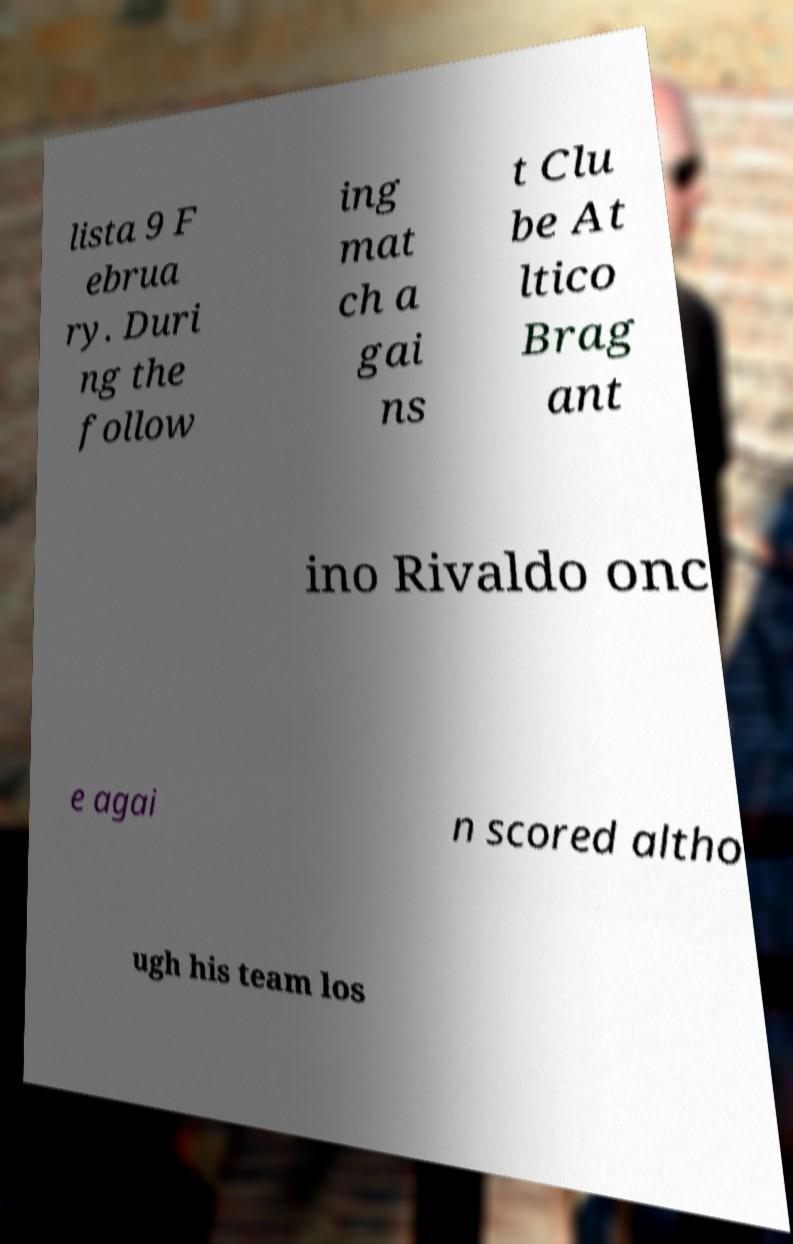What messages or text are displayed in this image? I need them in a readable, typed format. lista 9 F ebrua ry. Duri ng the follow ing mat ch a gai ns t Clu be At ltico Brag ant ino Rivaldo onc e agai n scored altho ugh his team los 